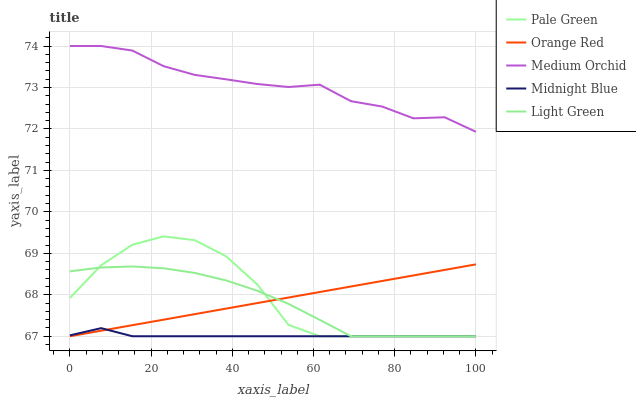Does Midnight Blue have the minimum area under the curve?
Answer yes or no. Yes. Does Medium Orchid have the maximum area under the curve?
Answer yes or no. Yes. Does Pale Green have the minimum area under the curve?
Answer yes or no. No. Does Pale Green have the maximum area under the curve?
Answer yes or no. No. Is Orange Red the smoothest?
Answer yes or no. Yes. Is Pale Green the roughest?
Answer yes or no. Yes. Is Pale Green the smoothest?
Answer yes or no. No. Is Orange Red the roughest?
Answer yes or no. No. Does Pale Green have the lowest value?
Answer yes or no. Yes. Does Medium Orchid have the highest value?
Answer yes or no. Yes. Does Pale Green have the highest value?
Answer yes or no. No. Is Pale Green less than Medium Orchid?
Answer yes or no. Yes. Is Medium Orchid greater than Pale Green?
Answer yes or no. Yes. Does Orange Red intersect Midnight Blue?
Answer yes or no. Yes. Is Orange Red less than Midnight Blue?
Answer yes or no. No. Is Orange Red greater than Midnight Blue?
Answer yes or no. No. Does Pale Green intersect Medium Orchid?
Answer yes or no. No. 